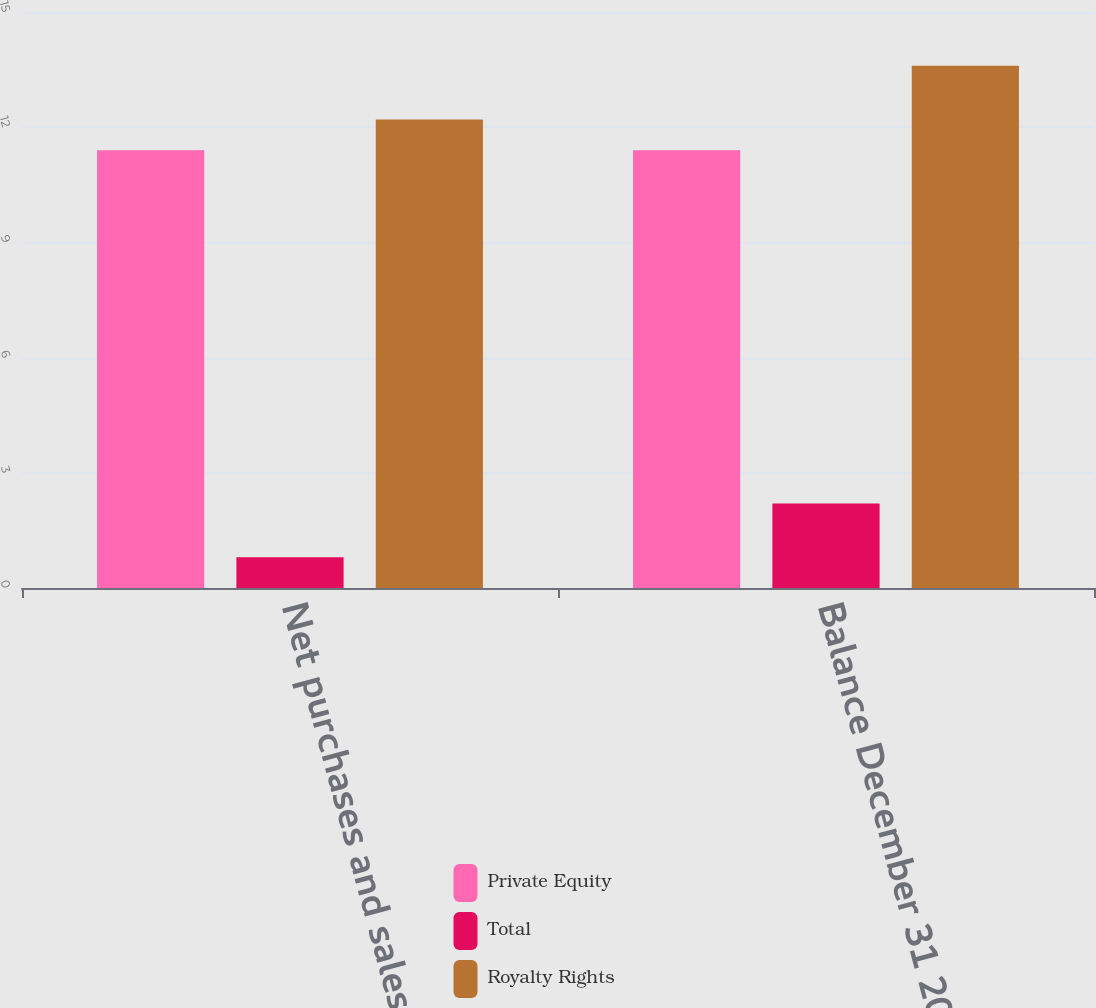Convert chart. <chart><loc_0><loc_0><loc_500><loc_500><stacked_bar_chart><ecel><fcel>Net purchases and sales<fcel>Balance December 31 2011<nl><fcel>Private Equity<fcel>11.4<fcel>11.4<nl><fcel>Total<fcel>0.8<fcel>2.2<nl><fcel>Royalty Rights<fcel>12.2<fcel>13.6<nl></chart> 